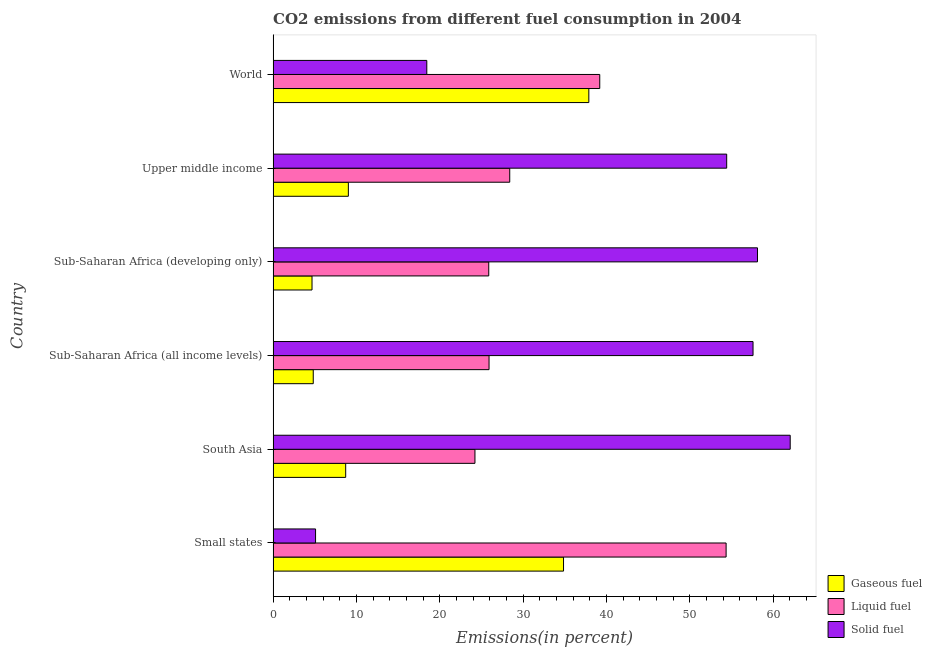How many groups of bars are there?
Make the answer very short. 6. Are the number of bars per tick equal to the number of legend labels?
Offer a very short reply. Yes. How many bars are there on the 3rd tick from the top?
Your response must be concise. 3. What is the label of the 3rd group of bars from the top?
Offer a very short reply. Sub-Saharan Africa (developing only). What is the percentage of solid fuel emission in Upper middle income?
Provide a short and direct response. 54.41. Across all countries, what is the maximum percentage of liquid fuel emission?
Offer a very short reply. 54.34. Across all countries, what is the minimum percentage of gaseous fuel emission?
Your answer should be compact. 4.67. In which country was the percentage of solid fuel emission maximum?
Make the answer very short. South Asia. In which country was the percentage of solid fuel emission minimum?
Provide a short and direct response. Small states. What is the total percentage of liquid fuel emission in the graph?
Keep it short and to the point. 197.89. What is the difference between the percentage of liquid fuel emission in South Asia and that in Sub-Saharan Africa (developing only)?
Give a very brief answer. -1.66. What is the difference between the percentage of liquid fuel emission in Sub-Saharan Africa (all income levels) and the percentage of gaseous fuel emission in Upper middle income?
Keep it short and to the point. 16.88. What is the average percentage of liquid fuel emission per country?
Your answer should be very brief. 32.98. What is the difference between the percentage of liquid fuel emission and percentage of solid fuel emission in Sub-Saharan Africa (all income levels)?
Offer a terse response. -31.67. In how many countries, is the percentage of gaseous fuel emission greater than 4 %?
Keep it short and to the point. 6. What is the ratio of the percentage of solid fuel emission in Small states to that in World?
Provide a short and direct response. 0.28. What is the difference between the highest and the second highest percentage of solid fuel emission?
Make the answer very short. 3.92. What is the difference between the highest and the lowest percentage of solid fuel emission?
Offer a terse response. 56.94. In how many countries, is the percentage of liquid fuel emission greater than the average percentage of liquid fuel emission taken over all countries?
Offer a very short reply. 2. Is the sum of the percentage of solid fuel emission in Upper middle income and World greater than the maximum percentage of liquid fuel emission across all countries?
Keep it short and to the point. Yes. What does the 2nd bar from the top in Sub-Saharan Africa (all income levels) represents?
Provide a succinct answer. Liquid fuel. What does the 1st bar from the bottom in South Asia represents?
Provide a short and direct response. Gaseous fuel. Is it the case that in every country, the sum of the percentage of gaseous fuel emission and percentage of liquid fuel emission is greater than the percentage of solid fuel emission?
Keep it short and to the point. No. How many bars are there?
Provide a succinct answer. 18. Are all the bars in the graph horizontal?
Offer a terse response. Yes. Are the values on the major ticks of X-axis written in scientific E-notation?
Offer a very short reply. No. Does the graph contain any zero values?
Your response must be concise. No. Does the graph contain grids?
Ensure brevity in your answer.  No. Where does the legend appear in the graph?
Offer a very short reply. Bottom right. How are the legend labels stacked?
Offer a terse response. Vertical. What is the title of the graph?
Your answer should be very brief. CO2 emissions from different fuel consumption in 2004. Does "Solid fuel" appear as one of the legend labels in the graph?
Your response must be concise. Yes. What is the label or title of the X-axis?
Provide a succinct answer. Emissions(in percent). What is the Emissions(in percent) of Gaseous fuel in Small states?
Offer a very short reply. 34.84. What is the Emissions(in percent) in Liquid fuel in Small states?
Ensure brevity in your answer.  54.34. What is the Emissions(in percent) in Solid fuel in Small states?
Provide a succinct answer. 5.09. What is the Emissions(in percent) of Gaseous fuel in South Asia?
Provide a succinct answer. 8.7. What is the Emissions(in percent) in Liquid fuel in South Asia?
Your response must be concise. 24.21. What is the Emissions(in percent) in Solid fuel in South Asia?
Make the answer very short. 62.03. What is the Emissions(in percent) in Gaseous fuel in Sub-Saharan Africa (all income levels)?
Give a very brief answer. 4.81. What is the Emissions(in percent) in Liquid fuel in Sub-Saharan Africa (all income levels)?
Provide a short and direct response. 25.9. What is the Emissions(in percent) of Solid fuel in Sub-Saharan Africa (all income levels)?
Your answer should be compact. 57.57. What is the Emissions(in percent) in Gaseous fuel in Sub-Saharan Africa (developing only)?
Offer a very short reply. 4.67. What is the Emissions(in percent) in Liquid fuel in Sub-Saharan Africa (developing only)?
Offer a very short reply. 25.87. What is the Emissions(in percent) of Solid fuel in Sub-Saharan Africa (developing only)?
Provide a succinct answer. 58.11. What is the Emissions(in percent) of Gaseous fuel in Upper middle income?
Give a very brief answer. 9.03. What is the Emissions(in percent) of Liquid fuel in Upper middle income?
Offer a terse response. 28.38. What is the Emissions(in percent) in Solid fuel in Upper middle income?
Offer a very short reply. 54.41. What is the Emissions(in percent) in Gaseous fuel in World?
Provide a succinct answer. 37.87. What is the Emissions(in percent) in Liquid fuel in World?
Offer a terse response. 39.18. What is the Emissions(in percent) of Solid fuel in World?
Make the answer very short. 18.44. Across all countries, what is the maximum Emissions(in percent) of Gaseous fuel?
Make the answer very short. 37.87. Across all countries, what is the maximum Emissions(in percent) of Liquid fuel?
Ensure brevity in your answer.  54.34. Across all countries, what is the maximum Emissions(in percent) in Solid fuel?
Ensure brevity in your answer.  62.03. Across all countries, what is the minimum Emissions(in percent) in Gaseous fuel?
Keep it short and to the point. 4.67. Across all countries, what is the minimum Emissions(in percent) in Liquid fuel?
Give a very brief answer. 24.21. Across all countries, what is the minimum Emissions(in percent) in Solid fuel?
Provide a short and direct response. 5.09. What is the total Emissions(in percent) in Gaseous fuel in the graph?
Ensure brevity in your answer.  99.92. What is the total Emissions(in percent) in Liquid fuel in the graph?
Ensure brevity in your answer.  197.89. What is the total Emissions(in percent) of Solid fuel in the graph?
Make the answer very short. 255.64. What is the difference between the Emissions(in percent) of Gaseous fuel in Small states and that in South Asia?
Offer a terse response. 26.13. What is the difference between the Emissions(in percent) in Liquid fuel in Small states and that in South Asia?
Offer a terse response. 30.13. What is the difference between the Emissions(in percent) of Solid fuel in Small states and that in South Asia?
Your answer should be very brief. -56.94. What is the difference between the Emissions(in percent) of Gaseous fuel in Small states and that in Sub-Saharan Africa (all income levels)?
Provide a succinct answer. 30.03. What is the difference between the Emissions(in percent) of Liquid fuel in Small states and that in Sub-Saharan Africa (all income levels)?
Make the answer very short. 28.44. What is the difference between the Emissions(in percent) of Solid fuel in Small states and that in Sub-Saharan Africa (all income levels)?
Make the answer very short. -52.48. What is the difference between the Emissions(in percent) in Gaseous fuel in Small states and that in Sub-Saharan Africa (developing only)?
Offer a terse response. 30.17. What is the difference between the Emissions(in percent) in Liquid fuel in Small states and that in Sub-Saharan Africa (developing only)?
Provide a short and direct response. 28.47. What is the difference between the Emissions(in percent) in Solid fuel in Small states and that in Sub-Saharan Africa (developing only)?
Your response must be concise. -53.01. What is the difference between the Emissions(in percent) of Gaseous fuel in Small states and that in Upper middle income?
Provide a short and direct response. 25.81. What is the difference between the Emissions(in percent) of Liquid fuel in Small states and that in Upper middle income?
Your answer should be compact. 25.96. What is the difference between the Emissions(in percent) of Solid fuel in Small states and that in Upper middle income?
Offer a very short reply. -49.32. What is the difference between the Emissions(in percent) of Gaseous fuel in Small states and that in World?
Your answer should be compact. -3.03. What is the difference between the Emissions(in percent) in Liquid fuel in Small states and that in World?
Your response must be concise. 15.16. What is the difference between the Emissions(in percent) of Solid fuel in Small states and that in World?
Your answer should be compact. -13.34. What is the difference between the Emissions(in percent) in Gaseous fuel in South Asia and that in Sub-Saharan Africa (all income levels)?
Keep it short and to the point. 3.89. What is the difference between the Emissions(in percent) in Liquid fuel in South Asia and that in Sub-Saharan Africa (all income levels)?
Offer a very short reply. -1.69. What is the difference between the Emissions(in percent) of Solid fuel in South Asia and that in Sub-Saharan Africa (all income levels)?
Offer a terse response. 4.46. What is the difference between the Emissions(in percent) in Gaseous fuel in South Asia and that in Sub-Saharan Africa (developing only)?
Offer a terse response. 4.04. What is the difference between the Emissions(in percent) in Liquid fuel in South Asia and that in Sub-Saharan Africa (developing only)?
Your answer should be very brief. -1.66. What is the difference between the Emissions(in percent) in Solid fuel in South Asia and that in Sub-Saharan Africa (developing only)?
Offer a terse response. 3.92. What is the difference between the Emissions(in percent) of Gaseous fuel in South Asia and that in Upper middle income?
Make the answer very short. -0.32. What is the difference between the Emissions(in percent) in Liquid fuel in South Asia and that in Upper middle income?
Your response must be concise. -4.17. What is the difference between the Emissions(in percent) in Solid fuel in South Asia and that in Upper middle income?
Provide a short and direct response. 7.62. What is the difference between the Emissions(in percent) in Gaseous fuel in South Asia and that in World?
Your response must be concise. -29.17. What is the difference between the Emissions(in percent) in Liquid fuel in South Asia and that in World?
Provide a succinct answer. -14.97. What is the difference between the Emissions(in percent) of Solid fuel in South Asia and that in World?
Your answer should be compact. 43.59. What is the difference between the Emissions(in percent) in Gaseous fuel in Sub-Saharan Africa (all income levels) and that in Sub-Saharan Africa (developing only)?
Make the answer very short. 0.15. What is the difference between the Emissions(in percent) in Liquid fuel in Sub-Saharan Africa (all income levels) and that in Sub-Saharan Africa (developing only)?
Provide a short and direct response. 0.03. What is the difference between the Emissions(in percent) of Solid fuel in Sub-Saharan Africa (all income levels) and that in Sub-Saharan Africa (developing only)?
Make the answer very short. -0.53. What is the difference between the Emissions(in percent) of Gaseous fuel in Sub-Saharan Africa (all income levels) and that in Upper middle income?
Your answer should be very brief. -4.21. What is the difference between the Emissions(in percent) in Liquid fuel in Sub-Saharan Africa (all income levels) and that in Upper middle income?
Your answer should be compact. -2.48. What is the difference between the Emissions(in percent) of Solid fuel in Sub-Saharan Africa (all income levels) and that in Upper middle income?
Offer a terse response. 3.16. What is the difference between the Emissions(in percent) of Gaseous fuel in Sub-Saharan Africa (all income levels) and that in World?
Your answer should be compact. -33.06. What is the difference between the Emissions(in percent) in Liquid fuel in Sub-Saharan Africa (all income levels) and that in World?
Your response must be concise. -13.28. What is the difference between the Emissions(in percent) in Solid fuel in Sub-Saharan Africa (all income levels) and that in World?
Make the answer very short. 39.14. What is the difference between the Emissions(in percent) in Gaseous fuel in Sub-Saharan Africa (developing only) and that in Upper middle income?
Your answer should be compact. -4.36. What is the difference between the Emissions(in percent) in Liquid fuel in Sub-Saharan Africa (developing only) and that in Upper middle income?
Provide a succinct answer. -2.52. What is the difference between the Emissions(in percent) in Solid fuel in Sub-Saharan Africa (developing only) and that in Upper middle income?
Your answer should be very brief. 3.69. What is the difference between the Emissions(in percent) in Gaseous fuel in Sub-Saharan Africa (developing only) and that in World?
Make the answer very short. -33.21. What is the difference between the Emissions(in percent) of Liquid fuel in Sub-Saharan Africa (developing only) and that in World?
Your response must be concise. -13.32. What is the difference between the Emissions(in percent) in Solid fuel in Sub-Saharan Africa (developing only) and that in World?
Provide a succinct answer. 39.67. What is the difference between the Emissions(in percent) of Gaseous fuel in Upper middle income and that in World?
Your answer should be compact. -28.85. What is the difference between the Emissions(in percent) of Liquid fuel in Upper middle income and that in World?
Offer a very short reply. -10.8. What is the difference between the Emissions(in percent) in Solid fuel in Upper middle income and that in World?
Make the answer very short. 35.98. What is the difference between the Emissions(in percent) in Gaseous fuel in Small states and the Emissions(in percent) in Liquid fuel in South Asia?
Your answer should be compact. 10.63. What is the difference between the Emissions(in percent) in Gaseous fuel in Small states and the Emissions(in percent) in Solid fuel in South Asia?
Ensure brevity in your answer.  -27.19. What is the difference between the Emissions(in percent) of Liquid fuel in Small states and the Emissions(in percent) of Solid fuel in South Asia?
Keep it short and to the point. -7.69. What is the difference between the Emissions(in percent) in Gaseous fuel in Small states and the Emissions(in percent) in Liquid fuel in Sub-Saharan Africa (all income levels)?
Ensure brevity in your answer.  8.94. What is the difference between the Emissions(in percent) in Gaseous fuel in Small states and the Emissions(in percent) in Solid fuel in Sub-Saharan Africa (all income levels)?
Provide a short and direct response. -22.73. What is the difference between the Emissions(in percent) of Liquid fuel in Small states and the Emissions(in percent) of Solid fuel in Sub-Saharan Africa (all income levels)?
Keep it short and to the point. -3.23. What is the difference between the Emissions(in percent) in Gaseous fuel in Small states and the Emissions(in percent) in Liquid fuel in Sub-Saharan Africa (developing only)?
Keep it short and to the point. 8.97. What is the difference between the Emissions(in percent) of Gaseous fuel in Small states and the Emissions(in percent) of Solid fuel in Sub-Saharan Africa (developing only)?
Provide a succinct answer. -23.27. What is the difference between the Emissions(in percent) in Liquid fuel in Small states and the Emissions(in percent) in Solid fuel in Sub-Saharan Africa (developing only)?
Your answer should be very brief. -3.76. What is the difference between the Emissions(in percent) of Gaseous fuel in Small states and the Emissions(in percent) of Liquid fuel in Upper middle income?
Offer a very short reply. 6.45. What is the difference between the Emissions(in percent) in Gaseous fuel in Small states and the Emissions(in percent) in Solid fuel in Upper middle income?
Provide a succinct answer. -19.57. What is the difference between the Emissions(in percent) of Liquid fuel in Small states and the Emissions(in percent) of Solid fuel in Upper middle income?
Ensure brevity in your answer.  -0.07. What is the difference between the Emissions(in percent) of Gaseous fuel in Small states and the Emissions(in percent) of Liquid fuel in World?
Keep it short and to the point. -4.34. What is the difference between the Emissions(in percent) of Gaseous fuel in Small states and the Emissions(in percent) of Solid fuel in World?
Offer a very short reply. 16.4. What is the difference between the Emissions(in percent) of Liquid fuel in Small states and the Emissions(in percent) of Solid fuel in World?
Offer a terse response. 35.91. What is the difference between the Emissions(in percent) of Gaseous fuel in South Asia and the Emissions(in percent) of Liquid fuel in Sub-Saharan Africa (all income levels)?
Offer a terse response. -17.2. What is the difference between the Emissions(in percent) of Gaseous fuel in South Asia and the Emissions(in percent) of Solid fuel in Sub-Saharan Africa (all income levels)?
Give a very brief answer. -48.87. What is the difference between the Emissions(in percent) in Liquid fuel in South Asia and the Emissions(in percent) in Solid fuel in Sub-Saharan Africa (all income levels)?
Provide a short and direct response. -33.36. What is the difference between the Emissions(in percent) in Gaseous fuel in South Asia and the Emissions(in percent) in Liquid fuel in Sub-Saharan Africa (developing only)?
Keep it short and to the point. -17.16. What is the difference between the Emissions(in percent) in Gaseous fuel in South Asia and the Emissions(in percent) in Solid fuel in Sub-Saharan Africa (developing only)?
Ensure brevity in your answer.  -49.4. What is the difference between the Emissions(in percent) of Liquid fuel in South Asia and the Emissions(in percent) of Solid fuel in Sub-Saharan Africa (developing only)?
Your response must be concise. -33.89. What is the difference between the Emissions(in percent) in Gaseous fuel in South Asia and the Emissions(in percent) in Liquid fuel in Upper middle income?
Ensure brevity in your answer.  -19.68. What is the difference between the Emissions(in percent) of Gaseous fuel in South Asia and the Emissions(in percent) of Solid fuel in Upper middle income?
Offer a terse response. -45.71. What is the difference between the Emissions(in percent) of Liquid fuel in South Asia and the Emissions(in percent) of Solid fuel in Upper middle income?
Keep it short and to the point. -30.2. What is the difference between the Emissions(in percent) of Gaseous fuel in South Asia and the Emissions(in percent) of Liquid fuel in World?
Ensure brevity in your answer.  -30.48. What is the difference between the Emissions(in percent) in Gaseous fuel in South Asia and the Emissions(in percent) in Solid fuel in World?
Your answer should be compact. -9.73. What is the difference between the Emissions(in percent) in Liquid fuel in South Asia and the Emissions(in percent) in Solid fuel in World?
Give a very brief answer. 5.78. What is the difference between the Emissions(in percent) in Gaseous fuel in Sub-Saharan Africa (all income levels) and the Emissions(in percent) in Liquid fuel in Sub-Saharan Africa (developing only)?
Offer a terse response. -21.05. What is the difference between the Emissions(in percent) of Gaseous fuel in Sub-Saharan Africa (all income levels) and the Emissions(in percent) of Solid fuel in Sub-Saharan Africa (developing only)?
Your response must be concise. -53.29. What is the difference between the Emissions(in percent) of Liquid fuel in Sub-Saharan Africa (all income levels) and the Emissions(in percent) of Solid fuel in Sub-Saharan Africa (developing only)?
Provide a short and direct response. -32.2. What is the difference between the Emissions(in percent) in Gaseous fuel in Sub-Saharan Africa (all income levels) and the Emissions(in percent) in Liquid fuel in Upper middle income?
Provide a succinct answer. -23.57. What is the difference between the Emissions(in percent) in Gaseous fuel in Sub-Saharan Africa (all income levels) and the Emissions(in percent) in Solid fuel in Upper middle income?
Keep it short and to the point. -49.6. What is the difference between the Emissions(in percent) in Liquid fuel in Sub-Saharan Africa (all income levels) and the Emissions(in percent) in Solid fuel in Upper middle income?
Offer a terse response. -28.51. What is the difference between the Emissions(in percent) in Gaseous fuel in Sub-Saharan Africa (all income levels) and the Emissions(in percent) in Liquid fuel in World?
Offer a very short reply. -34.37. What is the difference between the Emissions(in percent) in Gaseous fuel in Sub-Saharan Africa (all income levels) and the Emissions(in percent) in Solid fuel in World?
Keep it short and to the point. -13.62. What is the difference between the Emissions(in percent) in Liquid fuel in Sub-Saharan Africa (all income levels) and the Emissions(in percent) in Solid fuel in World?
Your answer should be compact. 7.47. What is the difference between the Emissions(in percent) in Gaseous fuel in Sub-Saharan Africa (developing only) and the Emissions(in percent) in Liquid fuel in Upper middle income?
Your response must be concise. -23.72. What is the difference between the Emissions(in percent) of Gaseous fuel in Sub-Saharan Africa (developing only) and the Emissions(in percent) of Solid fuel in Upper middle income?
Provide a succinct answer. -49.74. What is the difference between the Emissions(in percent) in Liquid fuel in Sub-Saharan Africa (developing only) and the Emissions(in percent) in Solid fuel in Upper middle income?
Give a very brief answer. -28.54. What is the difference between the Emissions(in percent) of Gaseous fuel in Sub-Saharan Africa (developing only) and the Emissions(in percent) of Liquid fuel in World?
Keep it short and to the point. -34.52. What is the difference between the Emissions(in percent) in Gaseous fuel in Sub-Saharan Africa (developing only) and the Emissions(in percent) in Solid fuel in World?
Offer a terse response. -13.77. What is the difference between the Emissions(in percent) of Liquid fuel in Sub-Saharan Africa (developing only) and the Emissions(in percent) of Solid fuel in World?
Offer a very short reply. 7.43. What is the difference between the Emissions(in percent) in Gaseous fuel in Upper middle income and the Emissions(in percent) in Liquid fuel in World?
Ensure brevity in your answer.  -30.16. What is the difference between the Emissions(in percent) in Gaseous fuel in Upper middle income and the Emissions(in percent) in Solid fuel in World?
Give a very brief answer. -9.41. What is the difference between the Emissions(in percent) of Liquid fuel in Upper middle income and the Emissions(in percent) of Solid fuel in World?
Your answer should be compact. 9.95. What is the average Emissions(in percent) of Gaseous fuel per country?
Provide a short and direct response. 16.65. What is the average Emissions(in percent) in Liquid fuel per country?
Provide a short and direct response. 32.98. What is the average Emissions(in percent) in Solid fuel per country?
Keep it short and to the point. 42.61. What is the difference between the Emissions(in percent) in Gaseous fuel and Emissions(in percent) in Liquid fuel in Small states?
Your answer should be very brief. -19.5. What is the difference between the Emissions(in percent) of Gaseous fuel and Emissions(in percent) of Solid fuel in Small states?
Provide a short and direct response. 29.75. What is the difference between the Emissions(in percent) of Liquid fuel and Emissions(in percent) of Solid fuel in Small states?
Your answer should be very brief. 49.25. What is the difference between the Emissions(in percent) of Gaseous fuel and Emissions(in percent) of Liquid fuel in South Asia?
Make the answer very short. -15.51. What is the difference between the Emissions(in percent) of Gaseous fuel and Emissions(in percent) of Solid fuel in South Asia?
Your answer should be very brief. -53.32. What is the difference between the Emissions(in percent) in Liquid fuel and Emissions(in percent) in Solid fuel in South Asia?
Your answer should be very brief. -37.82. What is the difference between the Emissions(in percent) in Gaseous fuel and Emissions(in percent) in Liquid fuel in Sub-Saharan Africa (all income levels)?
Give a very brief answer. -21.09. What is the difference between the Emissions(in percent) in Gaseous fuel and Emissions(in percent) in Solid fuel in Sub-Saharan Africa (all income levels)?
Provide a succinct answer. -52.76. What is the difference between the Emissions(in percent) of Liquid fuel and Emissions(in percent) of Solid fuel in Sub-Saharan Africa (all income levels)?
Your answer should be compact. -31.67. What is the difference between the Emissions(in percent) in Gaseous fuel and Emissions(in percent) in Liquid fuel in Sub-Saharan Africa (developing only)?
Offer a terse response. -21.2. What is the difference between the Emissions(in percent) of Gaseous fuel and Emissions(in percent) of Solid fuel in Sub-Saharan Africa (developing only)?
Keep it short and to the point. -53.44. What is the difference between the Emissions(in percent) in Liquid fuel and Emissions(in percent) in Solid fuel in Sub-Saharan Africa (developing only)?
Your answer should be compact. -32.24. What is the difference between the Emissions(in percent) of Gaseous fuel and Emissions(in percent) of Liquid fuel in Upper middle income?
Your answer should be compact. -19.36. What is the difference between the Emissions(in percent) in Gaseous fuel and Emissions(in percent) in Solid fuel in Upper middle income?
Offer a terse response. -45.39. What is the difference between the Emissions(in percent) in Liquid fuel and Emissions(in percent) in Solid fuel in Upper middle income?
Make the answer very short. -26.03. What is the difference between the Emissions(in percent) in Gaseous fuel and Emissions(in percent) in Liquid fuel in World?
Make the answer very short. -1.31. What is the difference between the Emissions(in percent) of Gaseous fuel and Emissions(in percent) of Solid fuel in World?
Your response must be concise. 19.44. What is the difference between the Emissions(in percent) in Liquid fuel and Emissions(in percent) in Solid fuel in World?
Provide a short and direct response. 20.75. What is the ratio of the Emissions(in percent) of Gaseous fuel in Small states to that in South Asia?
Keep it short and to the point. 4. What is the ratio of the Emissions(in percent) of Liquid fuel in Small states to that in South Asia?
Give a very brief answer. 2.24. What is the ratio of the Emissions(in percent) of Solid fuel in Small states to that in South Asia?
Keep it short and to the point. 0.08. What is the ratio of the Emissions(in percent) in Gaseous fuel in Small states to that in Sub-Saharan Africa (all income levels)?
Offer a terse response. 7.24. What is the ratio of the Emissions(in percent) in Liquid fuel in Small states to that in Sub-Saharan Africa (all income levels)?
Ensure brevity in your answer.  2.1. What is the ratio of the Emissions(in percent) of Solid fuel in Small states to that in Sub-Saharan Africa (all income levels)?
Give a very brief answer. 0.09. What is the ratio of the Emissions(in percent) of Gaseous fuel in Small states to that in Sub-Saharan Africa (developing only)?
Ensure brevity in your answer.  7.47. What is the ratio of the Emissions(in percent) in Liquid fuel in Small states to that in Sub-Saharan Africa (developing only)?
Your answer should be compact. 2.1. What is the ratio of the Emissions(in percent) in Solid fuel in Small states to that in Sub-Saharan Africa (developing only)?
Ensure brevity in your answer.  0.09. What is the ratio of the Emissions(in percent) of Gaseous fuel in Small states to that in Upper middle income?
Provide a short and direct response. 3.86. What is the ratio of the Emissions(in percent) in Liquid fuel in Small states to that in Upper middle income?
Your response must be concise. 1.91. What is the ratio of the Emissions(in percent) in Solid fuel in Small states to that in Upper middle income?
Keep it short and to the point. 0.09. What is the ratio of the Emissions(in percent) in Gaseous fuel in Small states to that in World?
Offer a very short reply. 0.92. What is the ratio of the Emissions(in percent) in Liquid fuel in Small states to that in World?
Ensure brevity in your answer.  1.39. What is the ratio of the Emissions(in percent) of Solid fuel in Small states to that in World?
Your response must be concise. 0.28. What is the ratio of the Emissions(in percent) in Gaseous fuel in South Asia to that in Sub-Saharan Africa (all income levels)?
Your answer should be compact. 1.81. What is the ratio of the Emissions(in percent) of Liquid fuel in South Asia to that in Sub-Saharan Africa (all income levels)?
Offer a terse response. 0.93. What is the ratio of the Emissions(in percent) of Solid fuel in South Asia to that in Sub-Saharan Africa (all income levels)?
Ensure brevity in your answer.  1.08. What is the ratio of the Emissions(in percent) in Gaseous fuel in South Asia to that in Sub-Saharan Africa (developing only)?
Make the answer very short. 1.87. What is the ratio of the Emissions(in percent) of Liquid fuel in South Asia to that in Sub-Saharan Africa (developing only)?
Ensure brevity in your answer.  0.94. What is the ratio of the Emissions(in percent) in Solid fuel in South Asia to that in Sub-Saharan Africa (developing only)?
Provide a short and direct response. 1.07. What is the ratio of the Emissions(in percent) of Gaseous fuel in South Asia to that in Upper middle income?
Provide a short and direct response. 0.96. What is the ratio of the Emissions(in percent) of Liquid fuel in South Asia to that in Upper middle income?
Provide a short and direct response. 0.85. What is the ratio of the Emissions(in percent) in Solid fuel in South Asia to that in Upper middle income?
Provide a succinct answer. 1.14. What is the ratio of the Emissions(in percent) of Gaseous fuel in South Asia to that in World?
Ensure brevity in your answer.  0.23. What is the ratio of the Emissions(in percent) of Liquid fuel in South Asia to that in World?
Ensure brevity in your answer.  0.62. What is the ratio of the Emissions(in percent) in Solid fuel in South Asia to that in World?
Ensure brevity in your answer.  3.36. What is the ratio of the Emissions(in percent) of Gaseous fuel in Sub-Saharan Africa (all income levels) to that in Sub-Saharan Africa (developing only)?
Give a very brief answer. 1.03. What is the ratio of the Emissions(in percent) of Liquid fuel in Sub-Saharan Africa (all income levels) to that in Sub-Saharan Africa (developing only)?
Keep it short and to the point. 1. What is the ratio of the Emissions(in percent) of Gaseous fuel in Sub-Saharan Africa (all income levels) to that in Upper middle income?
Ensure brevity in your answer.  0.53. What is the ratio of the Emissions(in percent) in Liquid fuel in Sub-Saharan Africa (all income levels) to that in Upper middle income?
Offer a very short reply. 0.91. What is the ratio of the Emissions(in percent) of Solid fuel in Sub-Saharan Africa (all income levels) to that in Upper middle income?
Your response must be concise. 1.06. What is the ratio of the Emissions(in percent) of Gaseous fuel in Sub-Saharan Africa (all income levels) to that in World?
Offer a terse response. 0.13. What is the ratio of the Emissions(in percent) of Liquid fuel in Sub-Saharan Africa (all income levels) to that in World?
Offer a terse response. 0.66. What is the ratio of the Emissions(in percent) of Solid fuel in Sub-Saharan Africa (all income levels) to that in World?
Give a very brief answer. 3.12. What is the ratio of the Emissions(in percent) of Gaseous fuel in Sub-Saharan Africa (developing only) to that in Upper middle income?
Your answer should be very brief. 0.52. What is the ratio of the Emissions(in percent) in Liquid fuel in Sub-Saharan Africa (developing only) to that in Upper middle income?
Offer a terse response. 0.91. What is the ratio of the Emissions(in percent) in Solid fuel in Sub-Saharan Africa (developing only) to that in Upper middle income?
Keep it short and to the point. 1.07. What is the ratio of the Emissions(in percent) of Gaseous fuel in Sub-Saharan Africa (developing only) to that in World?
Give a very brief answer. 0.12. What is the ratio of the Emissions(in percent) in Liquid fuel in Sub-Saharan Africa (developing only) to that in World?
Provide a succinct answer. 0.66. What is the ratio of the Emissions(in percent) in Solid fuel in Sub-Saharan Africa (developing only) to that in World?
Your answer should be compact. 3.15. What is the ratio of the Emissions(in percent) of Gaseous fuel in Upper middle income to that in World?
Provide a succinct answer. 0.24. What is the ratio of the Emissions(in percent) of Liquid fuel in Upper middle income to that in World?
Provide a short and direct response. 0.72. What is the ratio of the Emissions(in percent) in Solid fuel in Upper middle income to that in World?
Keep it short and to the point. 2.95. What is the difference between the highest and the second highest Emissions(in percent) in Gaseous fuel?
Your response must be concise. 3.03. What is the difference between the highest and the second highest Emissions(in percent) of Liquid fuel?
Your answer should be very brief. 15.16. What is the difference between the highest and the second highest Emissions(in percent) of Solid fuel?
Your answer should be very brief. 3.92. What is the difference between the highest and the lowest Emissions(in percent) of Gaseous fuel?
Your answer should be compact. 33.21. What is the difference between the highest and the lowest Emissions(in percent) in Liquid fuel?
Your answer should be very brief. 30.13. What is the difference between the highest and the lowest Emissions(in percent) of Solid fuel?
Offer a very short reply. 56.94. 